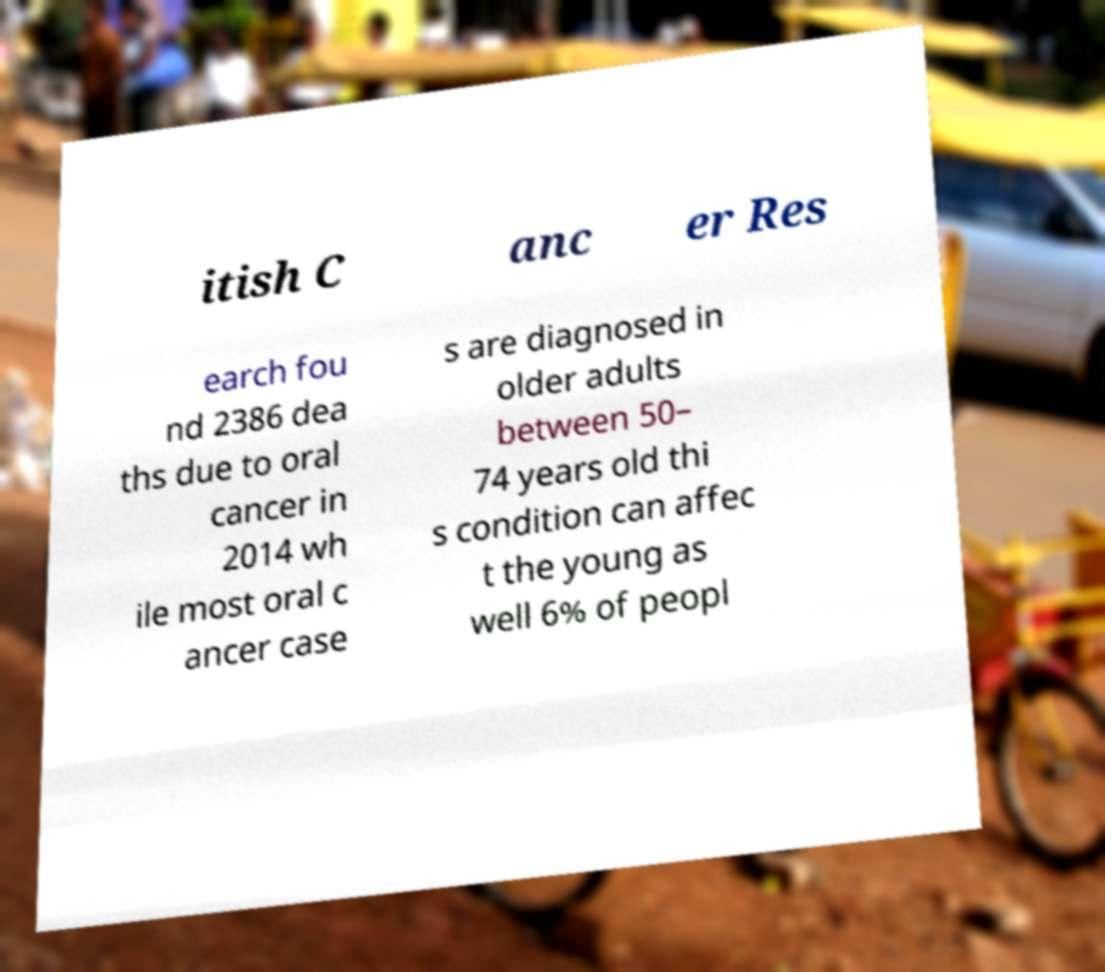What messages or text are displayed in this image? I need them in a readable, typed format. itish C anc er Res earch fou nd 2386 dea ths due to oral cancer in 2014 wh ile most oral c ancer case s are diagnosed in older adults between 50– 74 years old thi s condition can affec t the young as well 6% of peopl 